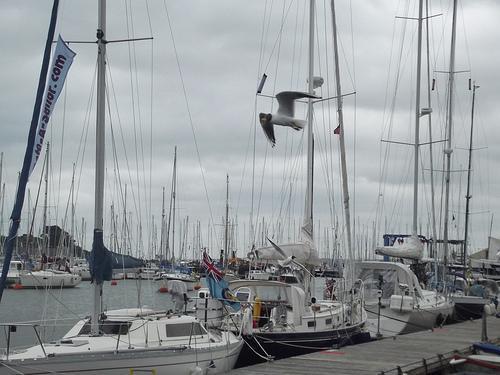How many birds are shown in the photo?
Give a very brief answer. 1. 